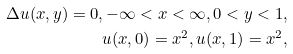<formula> <loc_0><loc_0><loc_500><loc_500>\Delta u ( x , y ) = 0 , - \infty < x < \infty , 0 < y < 1 , \\ u ( x , 0 ) = x ^ { 2 } , u ( x , 1 ) = x ^ { 2 } ,</formula> 